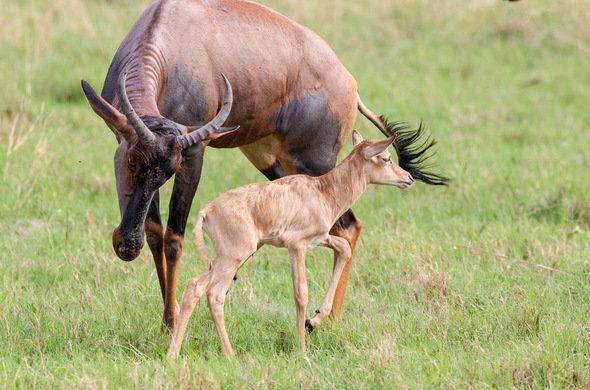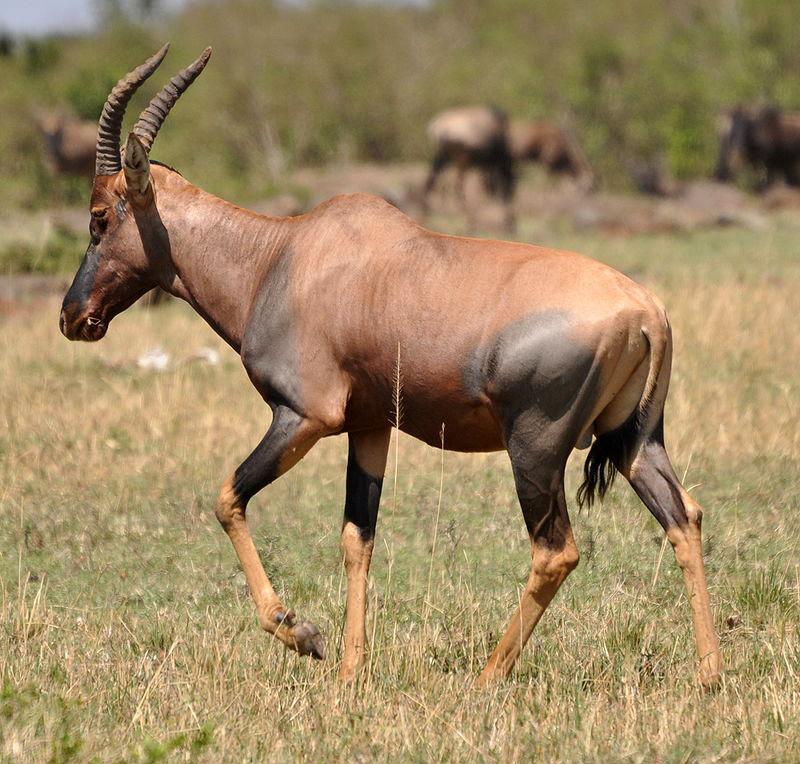The first image is the image on the left, the second image is the image on the right. Given the left and right images, does the statement "There is no more than one antelope in the right image facing right." hold true? Answer yes or no. No. The first image is the image on the left, the second image is the image on the right. Given the left and right images, does the statement "A young hooved animal without big horns stands facing right, in front of at least one big-horned animal." hold true? Answer yes or no. Yes. 